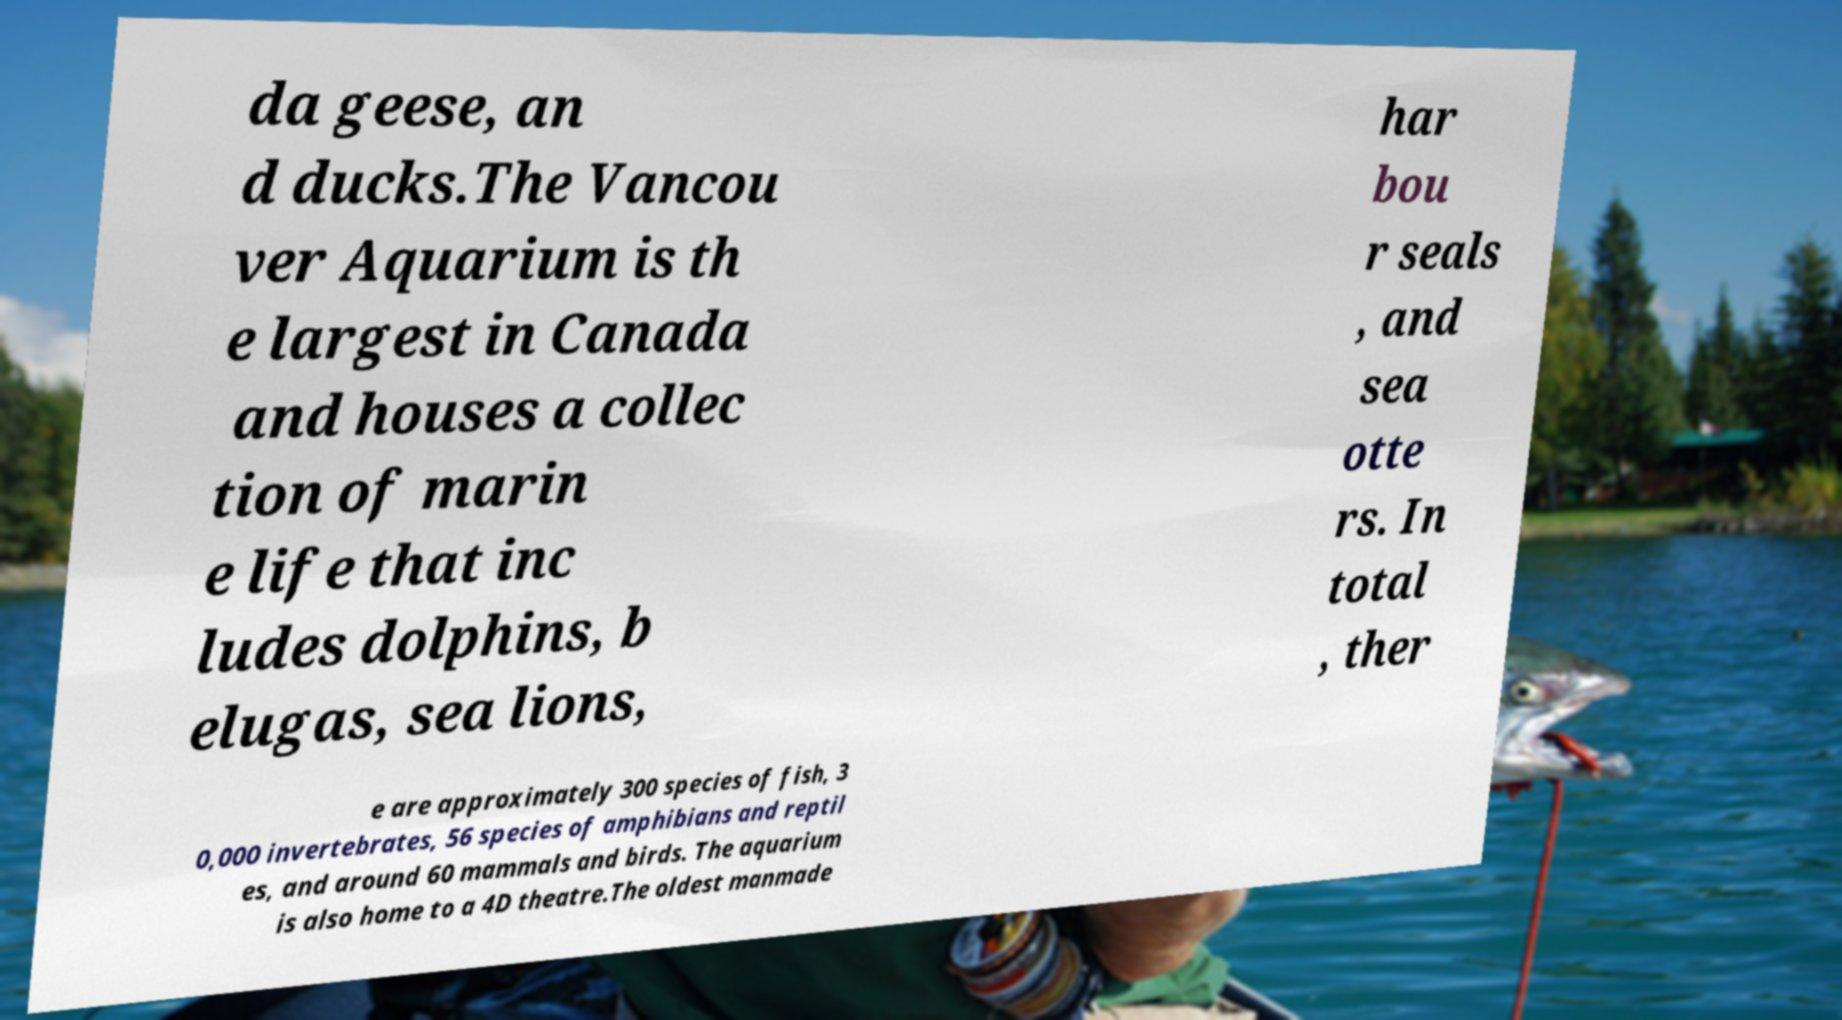For documentation purposes, I need the text within this image transcribed. Could you provide that? da geese, an d ducks.The Vancou ver Aquarium is th e largest in Canada and houses a collec tion of marin e life that inc ludes dolphins, b elugas, sea lions, har bou r seals , and sea otte rs. In total , ther e are approximately 300 species of fish, 3 0,000 invertebrates, 56 species of amphibians and reptil es, and around 60 mammals and birds. The aquarium is also home to a 4D theatre.The oldest manmade 